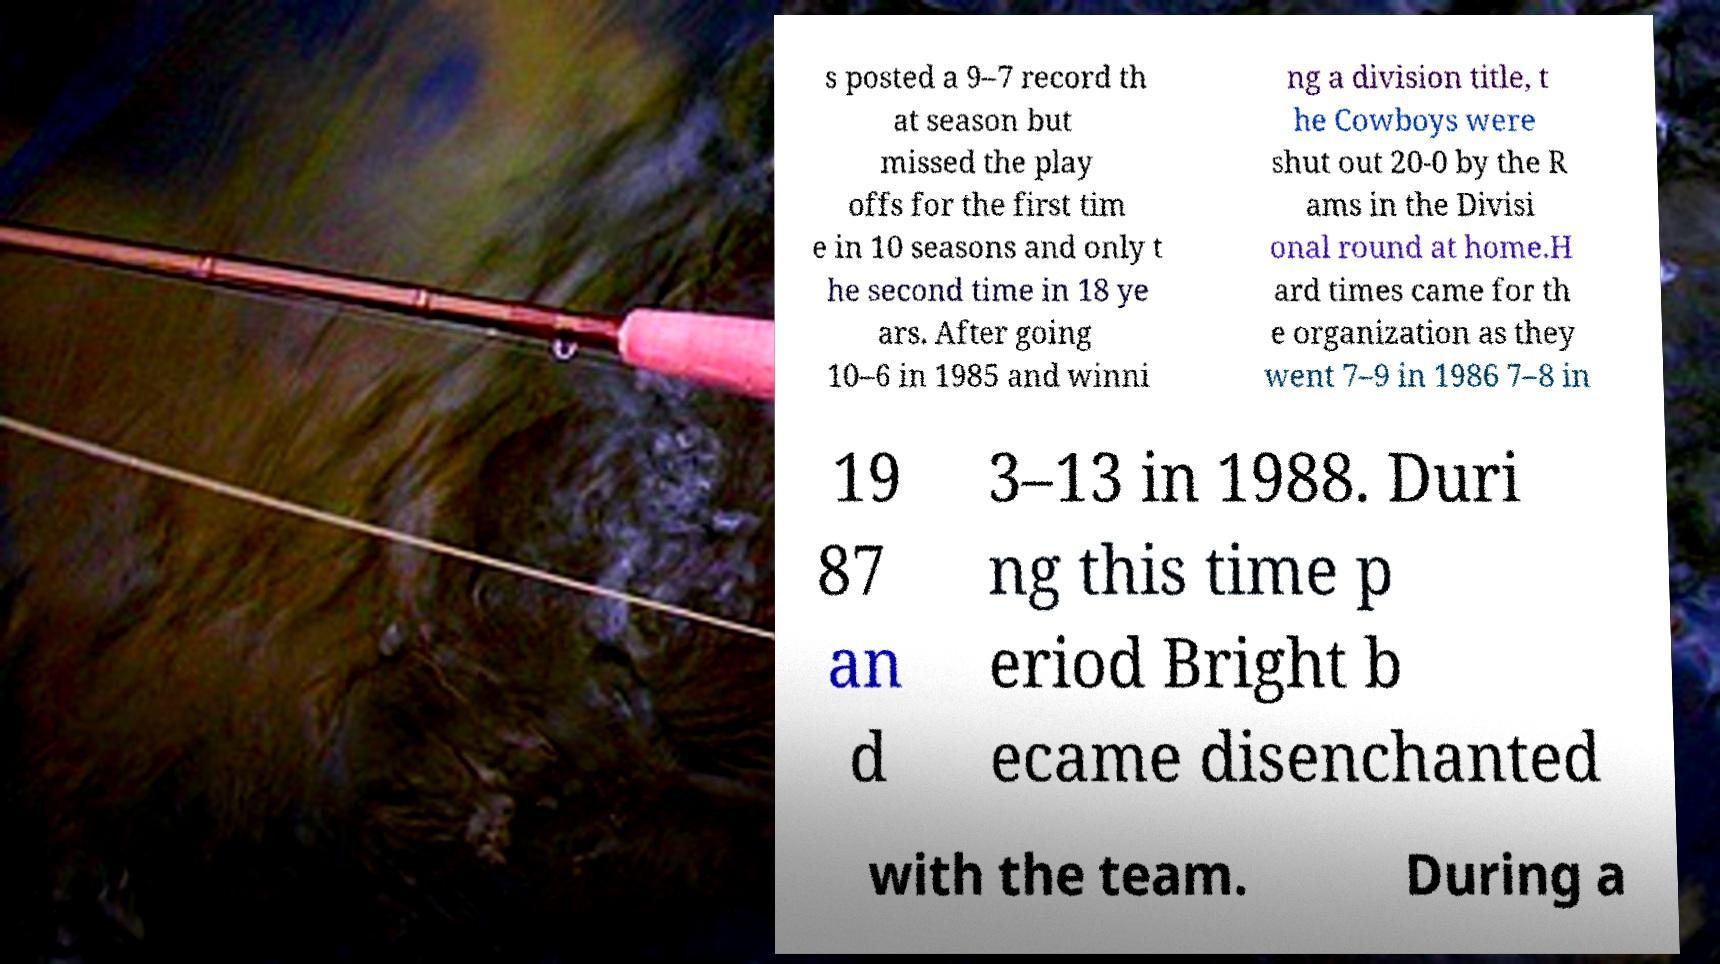What messages or text are displayed in this image? I need them in a readable, typed format. s posted a 9–7 record th at season but missed the play offs for the first tim e in 10 seasons and only t he second time in 18 ye ars. After going 10–6 in 1985 and winni ng a division title, t he Cowboys were shut out 20-0 by the R ams in the Divisi onal round at home.H ard times came for th e organization as they went 7–9 in 1986 7–8 in 19 87 an d 3–13 in 1988. Duri ng this time p eriod Bright b ecame disenchanted with the team. During a 